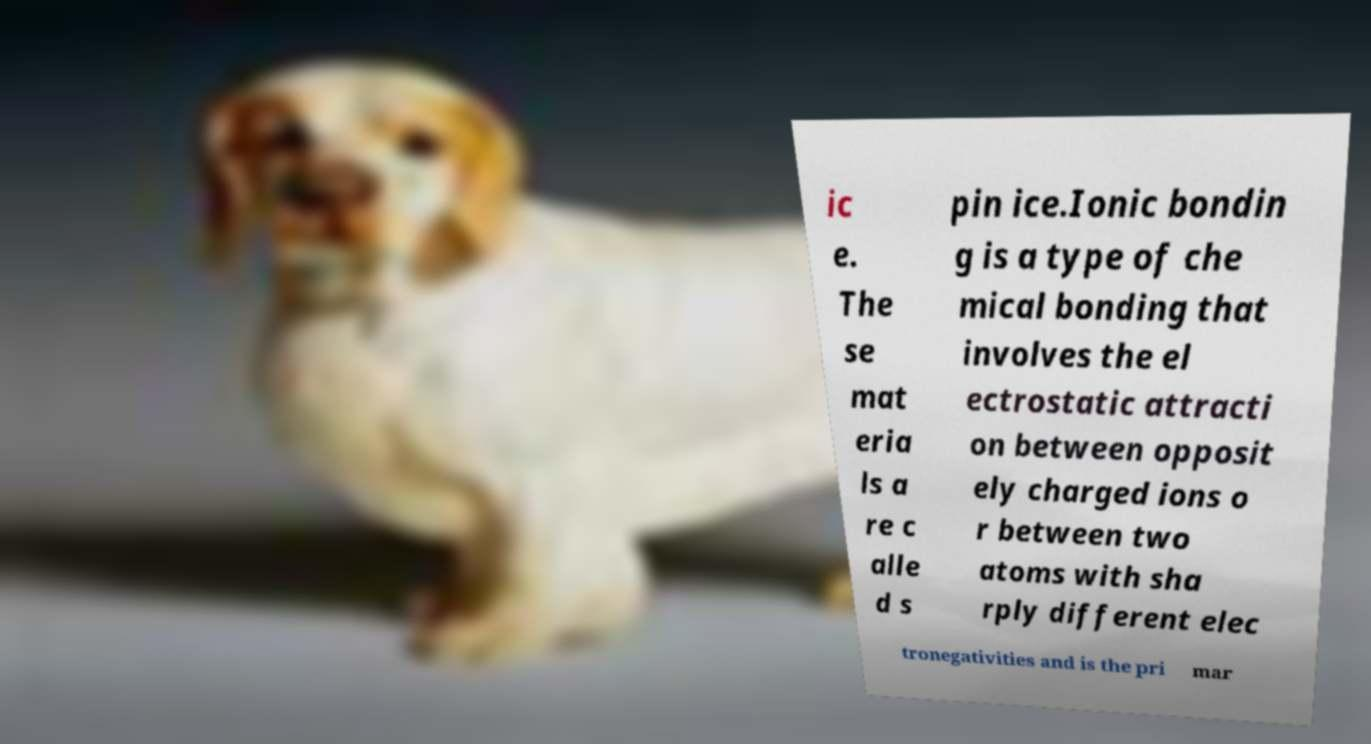Can you read and provide the text displayed in the image?This photo seems to have some interesting text. Can you extract and type it out for me? ic e. The se mat eria ls a re c alle d s pin ice.Ionic bondin g is a type of che mical bonding that involves the el ectrostatic attracti on between opposit ely charged ions o r between two atoms with sha rply different elec tronegativities and is the pri mar 